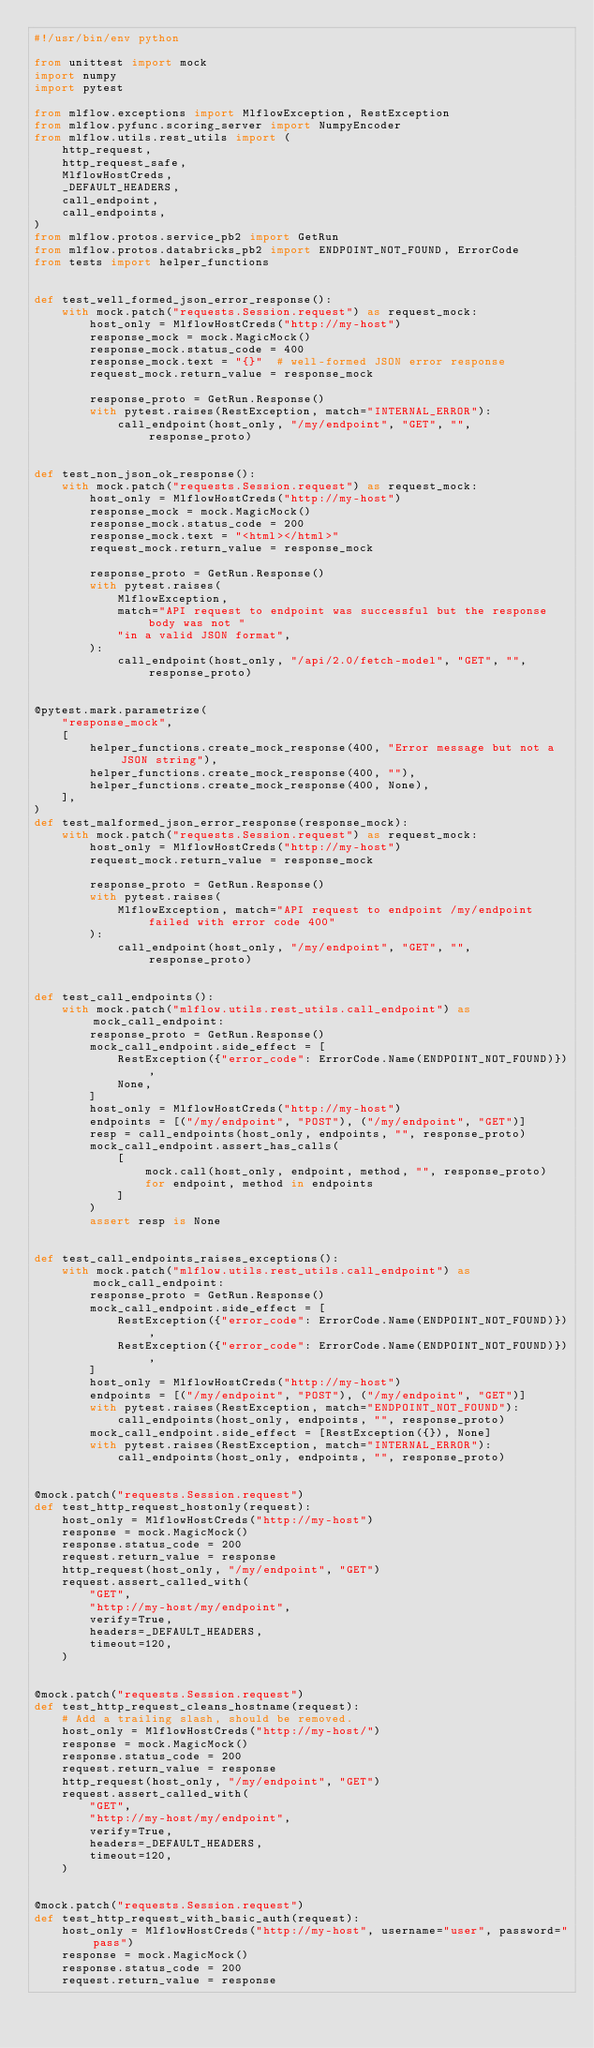Convert code to text. <code><loc_0><loc_0><loc_500><loc_500><_Python_>#!/usr/bin/env python

from unittest import mock
import numpy
import pytest

from mlflow.exceptions import MlflowException, RestException
from mlflow.pyfunc.scoring_server import NumpyEncoder
from mlflow.utils.rest_utils import (
    http_request,
    http_request_safe,
    MlflowHostCreds,
    _DEFAULT_HEADERS,
    call_endpoint,
    call_endpoints,
)
from mlflow.protos.service_pb2 import GetRun
from mlflow.protos.databricks_pb2 import ENDPOINT_NOT_FOUND, ErrorCode
from tests import helper_functions


def test_well_formed_json_error_response():
    with mock.patch("requests.Session.request") as request_mock:
        host_only = MlflowHostCreds("http://my-host")
        response_mock = mock.MagicMock()
        response_mock.status_code = 400
        response_mock.text = "{}"  # well-formed JSON error response
        request_mock.return_value = response_mock

        response_proto = GetRun.Response()
        with pytest.raises(RestException, match="INTERNAL_ERROR"):
            call_endpoint(host_only, "/my/endpoint", "GET", "", response_proto)


def test_non_json_ok_response():
    with mock.patch("requests.Session.request") as request_mock:
        host_only = MlflowHostCreds("http://my-host")
        response_mock = mock.MagicMock()
        response_mock.status_code = 200
        response_mock.text = "<html></html>"
        request_mock.return_value = response_mock

        response_proto = GetRun.Response()
        with pytest.raises(
            MlflowException,
            match="API request to endpoint was successful but the response body was not "
            "in a valid JSON format",
        ):
            call_endpoint(host_only, "/api/2.0/fetch-model", "GET", "", response_proto)


@pytest.mark.parametrize(
    "response_mock",
    [
        helper_functions.create_mock_response(400, "Error message but not a JSON string"),
        helper_functions.create_mock_response(400, ""),
        helper_functions.create_mock_response(400, None),
    ],
)
def test_malformed_json_error_response(response_mock):
    with mock.patch("requests.Session.request") as request_mock:
        host_only = MlflowHostCreds("http://my-host")
        request_mock.return_value = response_mock

        response_proto = GetRun.Response()
        with pytest.raises(
            MlflowException, match="API request to endpoint /my/endpoint failed with error code 400"
        ):
            call_endpoint(host_only, "/my/endpoint", "GET", "", response_proto)


def test_call_endpoints():
    with mock.patch("mlflow.utils.rest_utils.call_endpoint") as mock_call_endpoint:
        response_proto = GetRun.Response()
        mock_call_endpoint.side_effect = [
            RestException({"error_code": ErrorCode.Name(ENDPOINT_NOT_FOUND)}),
            None,
        ]
        host_only = MlflowHostCreds("http://my-host")
        endpoints = [("/my/endpoint", "POST"), ("/my/endpoint", "GET")]
        resp = call_endpoints(host_only, endpoints, "", response_proto)
        mock_call_endpoint.assert_has_calls(
            [
                mock.call(host_only, endpoint, method, "", response_proto)
                for endpoint, method in endpoints
            ]
        )
        assert resp is None


def test_call_endpoints_raises_exceptions():
    with mock.patch("mlflow.utils.rest_utils.call_endpoint") as mock_call_endpoint:
        response_proto = GetRun.Response()
        mock_call_endpoint.side_effect = [
            RestException({"error_code": ErrorCode.Name(ENDPOINT_NOT_FOUND)}),
            RestException({"error_code": ErrorCode.Name(ENDPOINT_NOT_FOUND)}),
        ]
        host_only = MlflowHostCreds("http://my-host")
        endpoints = [("/my/endpoint", "POST"), ("/my/endpoint", "GET")]
        with pytest.raises(RestException, match="ENDPOINT_NOT_FOUND"):
            call_endpoints(host_only, endpoints, "", response_proto)
        mock_call_endpoint.side_effect = [RestException({}), None]
        with pytest.raises(RestException, match="INTERNAL_ERROR"):
            call_endpoints(host_only, endpoints, "", response_proto)


@mock.patch("requests.Session.request")
def test_http_request_hostonly(request):
    host_only = MlflowHostCreds("http://my-host")
    response = mock.MagicMock()
    response.status_code = 200
    request.return_value = response
    http_request(host_only, "/my/endpoint", "GET")
    request.assert_called_with(
        "GET",
        "http://my-host/my/endpoint",
        verify=True,
        headers=_DEFAULT_HEADERS,
        timeout=120,
    )


@mock.patch("requests.Session.request")
def test_http_request_cleans_hostname(request):
    # Add a trailing slash, should be removed.
    host_only = MlflowHostCreds("http://my-host/")
    response = mock.MagicMock()
    response.status_code = 200
    request.return_value = response
    http_request(host_only, "/my/endpoint", "GET")
    request.assert_called_with(
        "GET",
        "http://my-host/my/endpoint",
        verify=True,
        headers=_DEFAULT_HEADERS,
        timeout=120,
    )


@mock.patch("requests.Session.request")
def test_http_request_with_basic_auth(request):
    host_only = MlflowHostCreds("http://my-host", username="user", password="pass")
    response = mock.MagicMock()
    response.status_code = 200
    request.return_value = response</code> 